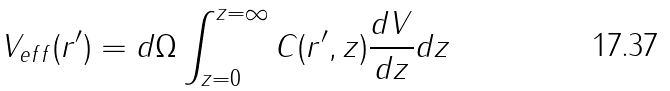<formula> <loc_0><loc_0><loc_500><loc_500>V _ { e f f } ( r ^ { \prime } ) = d \Omega \int _ { z = 0 } ^ { z = \infty } C ( r ^ { \prime } , z ) \frac { d V } { d z } d z</formula> 